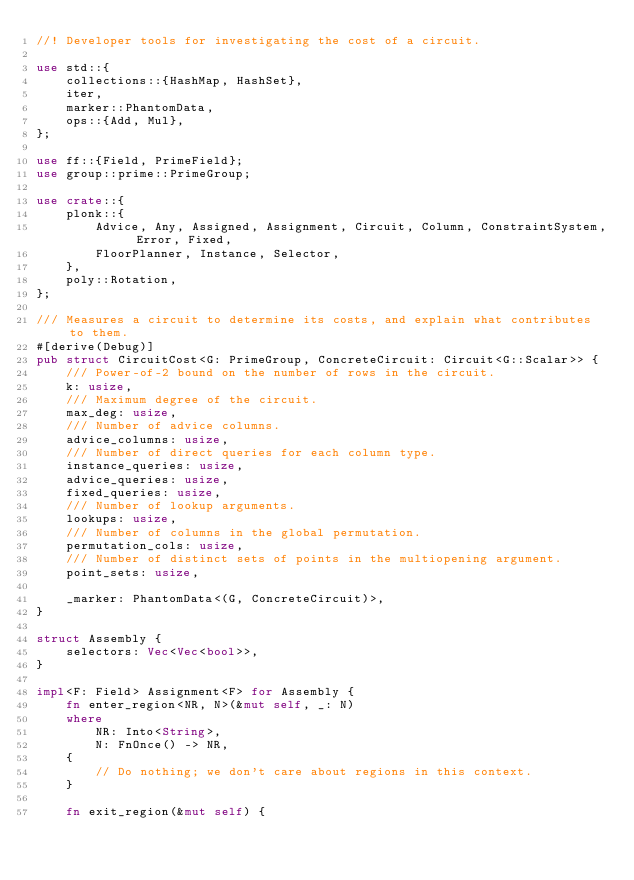Convert code to text. <code><loc_0><loc_0><loc_500><loc_500><_Rust_>//! Developer tools for investigating the cost of a circuit.

use std::{
    collections::{HashMap, HashSet},
    iter,
    marker::PhantomData,
    ops::{Add, Mul},
};

use ff::{Field, PrimeField};
use group::prime::PrimeGroup;

use crate::{
    plonk::{
        Advice, Any, Assigned, Assignment, Circuit, Column, ConstraintSystem, Error, Fixed,
        FloorPlanner, Instance, Selector,
    },
    poly::Rotation,
};

/// Measures a circuit to determine its costs, and explain what contributes to them.
#[derive(Debug)]
pub struct CircuitCost<G: PrimeGroup, ConcreteCircuit: Circuit<G::Scalar>> {
    /// Power-of-2 bound on the number of rows in the circuit.
    k: usize,
    /// Maximum degree of the circuit.
    max_deg: usize,
    /// Number of advice columns.
    advice_columns: usize,
    /// Number of direct queries for each column type.
    instance_queries: usize,
    advice_queries: usize,
    fixed_queries: usize,
    /// Number of lookup arguments.
    lookups: usize,
    /// Number of columns in the global permutation.
    permutation_cols: usize,
    /// Number of distinct sets of points in the multiopening argument.
    point_sets: usize,

    _marker: PhantomData<(G, ConcreteCircuit)>,
}

struct Assembly {
    selectors: Vec<Vec<bool>>,
}

impl<F: Field> Assignment<F> for Assembly {
    fn enter_region<NR, N>(&mut self, _: N)
    where
        NR: Into<String>,
        N: FnOnce() -> NR,
    {
        // Do nothing; we don't care about regions in this context.
    }

    fn exit_region(&mut self) {</code> 